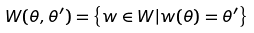Convert formula to latex. <formula><loc_0><loc_0><loc_500><loc_500>W ( \theta , \theta ^ { \prime } ) = \left \{ w \in W | w ( \theta ) = \theta ^ { \prime } \right \}</formula> 